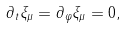<formula> <loc_0><loc_0><loc_500><loc_500>\partial _ { t } \xi _ { \mu } = \partial _ { \varphi } \xi _ { \mu } = 0 ,</formula> 